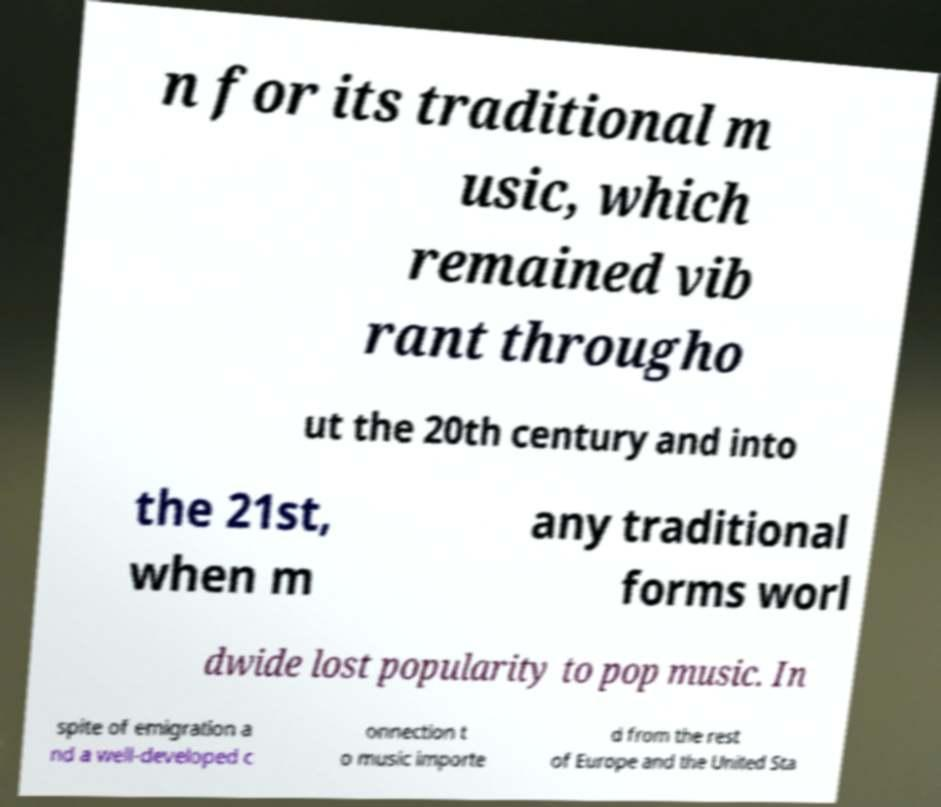Can you accurately transcribe the text from the provided image for me? n for its traditional m usic, which remained vib rant througho ut the 20th century and into the 21st, when m any traditional forms worl dwide lost popularity to pop music. In spite of emigration a nd a well-developed c onnection t o music importe d from the rest of Europe and the United Sta 